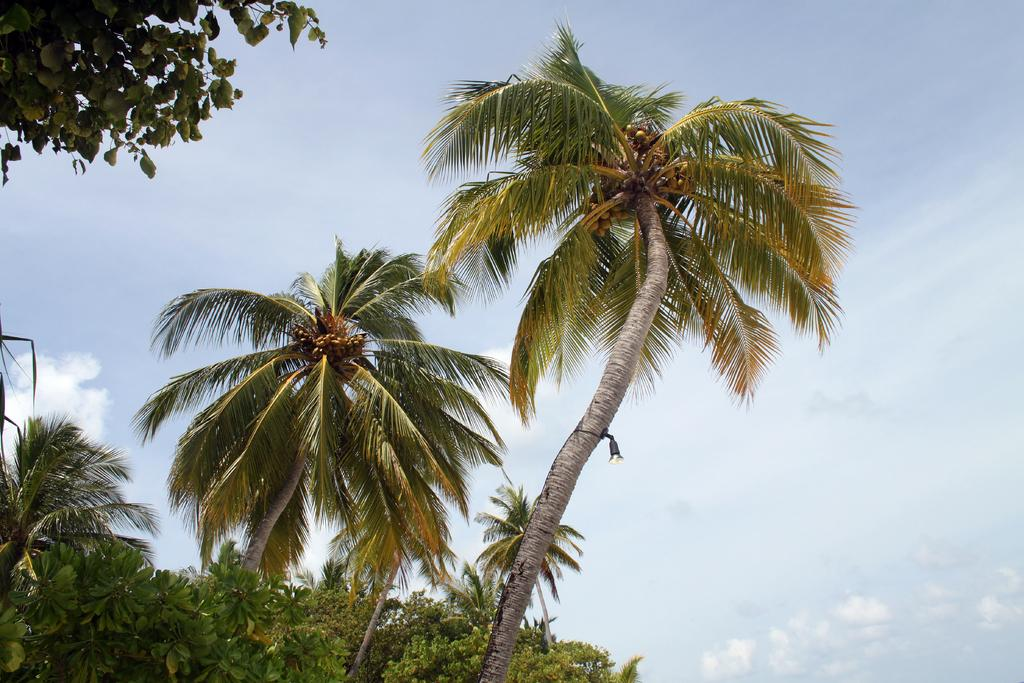What type of trees are in the middle of the picture? There are coconut trees in the middle of the picture. What can be seen towards the left side of the picture? There are trees towards the left side of the picture. What specific parts of plants are visible in the top left corner of the image? Leaves and stems are present in the top left corner of the image. What is visible in the background of the image? The background of the image is the sky. How many sheep are visible in the image? There are no sheep present in the image. What type of sheet is covering the trees in the image? There is no sheet present in the image; it features coconut trees, other trees, and leaves and stems. 